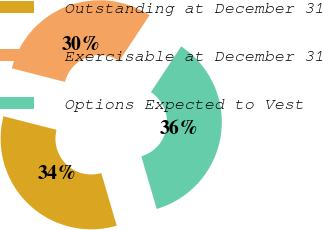<chart> <loc_0><loc_0><loc_500><loc_500><pie_chart><fcel>Outstanding at December 31<fcel>Exercisable at December 31<fcel>Options Expected to Vest<nl><fcel>33.53%<fcel>30.31%<fcel>36.17%<nl></chart> 